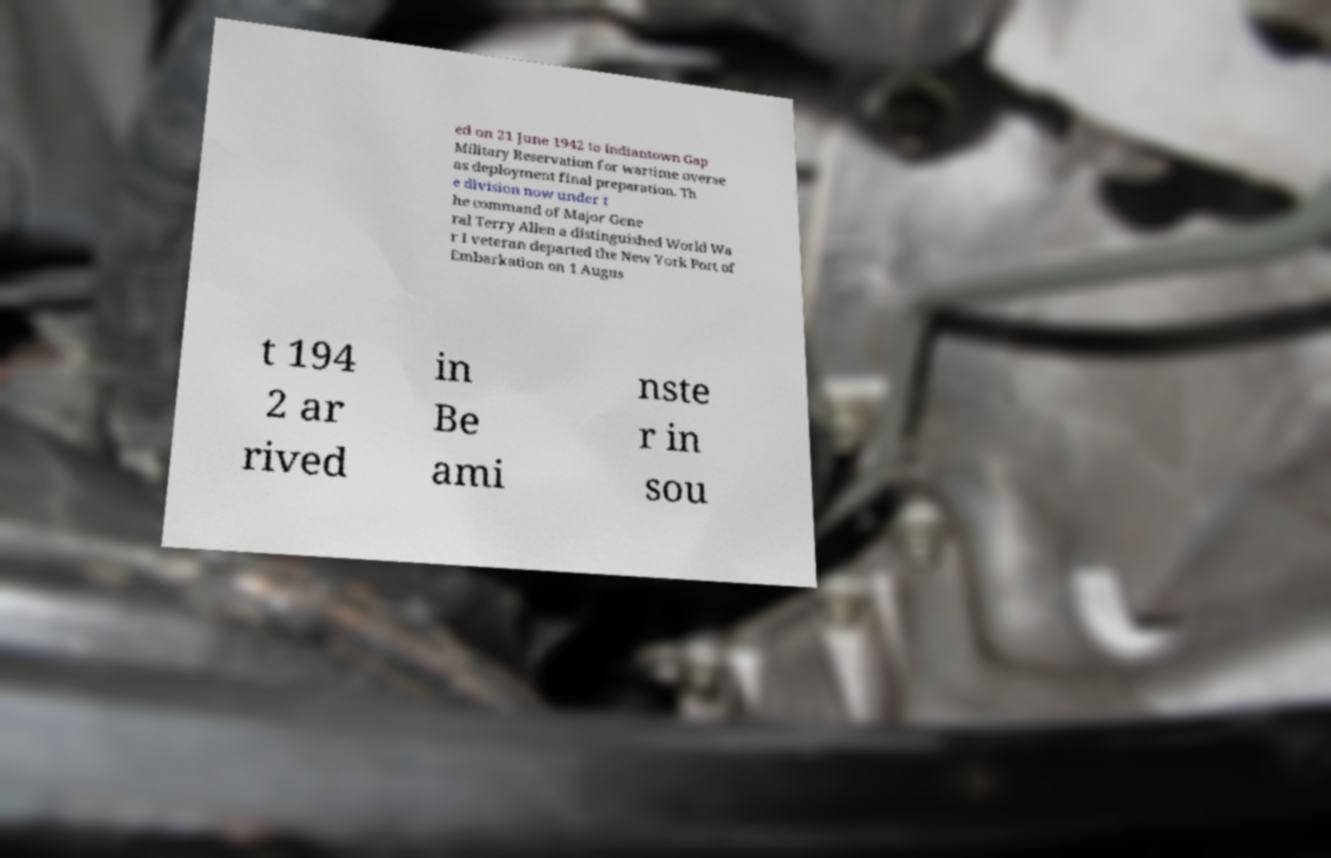For documentation purposes, I need the text within this image transcribed. Could you provide that? ed on 21 June 1942 to Indiantown Gap Military Reservation for wartime overse as deployment final preparation. Th e division now under t he command of Major Gene ral Terry Allen a distinguished World Wa r I veteran departed the New York Port of Embarkation on 1 Augus t 194 2 ar rived in Be ami nste r in sou 